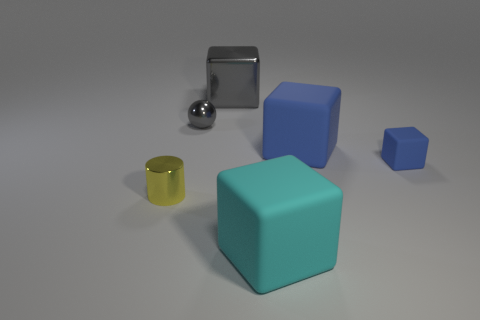How many blue cubes must be subtracted to get 1 blue cubes? 1 Subtract all brown cylinders. How many blue blocks are left? 2 Subtract all cyan matte blocks. How many blocks are left? 3 Subtract all cyan blocks. How many blocks are left? 3 Add 1 green blocks. How many objects exist? 7 Subtract all purple cubes. Subtract all cyan spheres. How many cubes are left? 4 Subtract all cubes. How many objects are left? 2 Subtract all large things. Subtract all big green matte things. How many objects are left? 3 Add 4 matte cubes. How many matte cubes are left? 7 Add 3 large gray rubber cylinders. How many large gray rubber cylinders exist? 3 